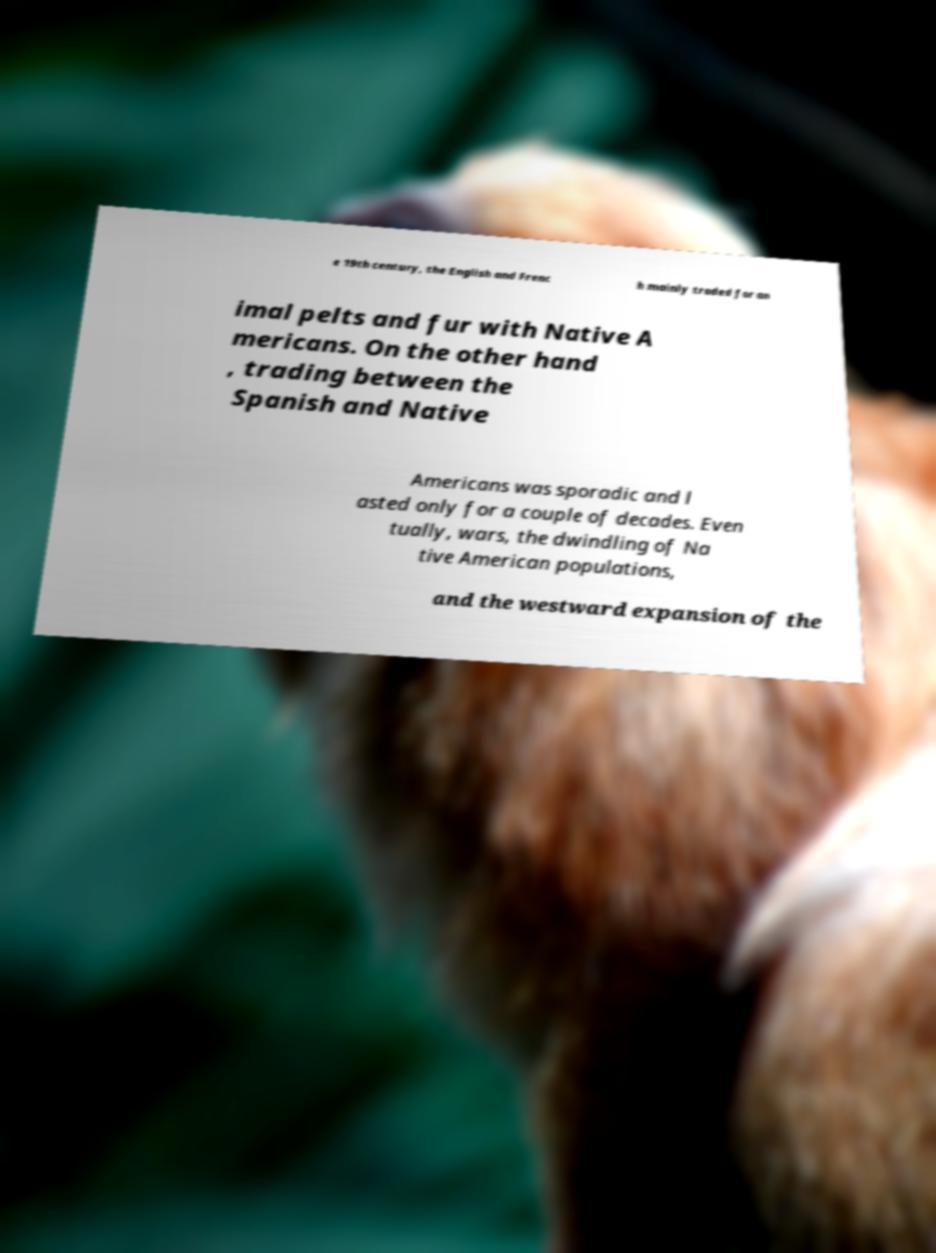What messages or text are displayed in this image? I need them in a readable, typed format. e 19th century, the English and Frenc h mainly traded for an imal pelts and fur with Native A mericans. On the other hand , trading between the Spanish and Native Americans was sporadic and l asted only for a couple of decades. Even tually, wars, the dwindling of Na tive American populations, and the westward expansion of the 